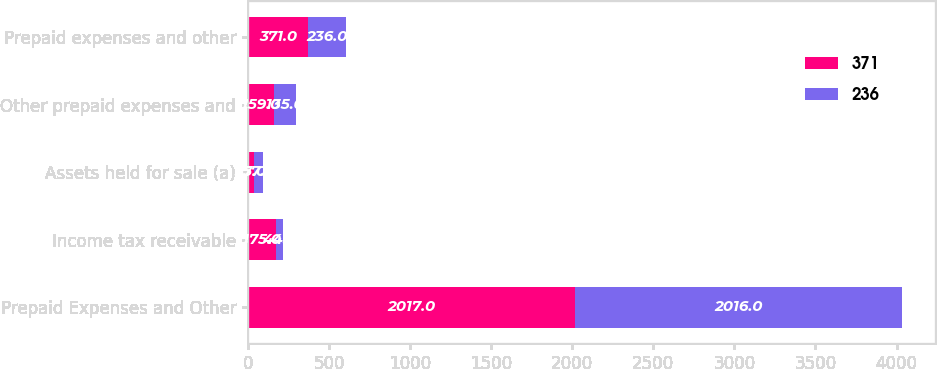<chart> <loc_0><loc_0><loc_500><loc_500><stacked_bar_chart><ecel><fcel>Prepaid Expenses and Other<fcel>Income tax receivable<fcel>Assets held for sale (a)<fcel>Other prepaid expenses and<fcel>Prepaid expenses and other<nl><fcel>371<fcel>2017<fcel>175<fcel>37<fcel>159<fcel>371<nl><fcel>236<fcel>2016<fcel>44<fcel>57<fcel>135<fcel>236<nl></chart> 